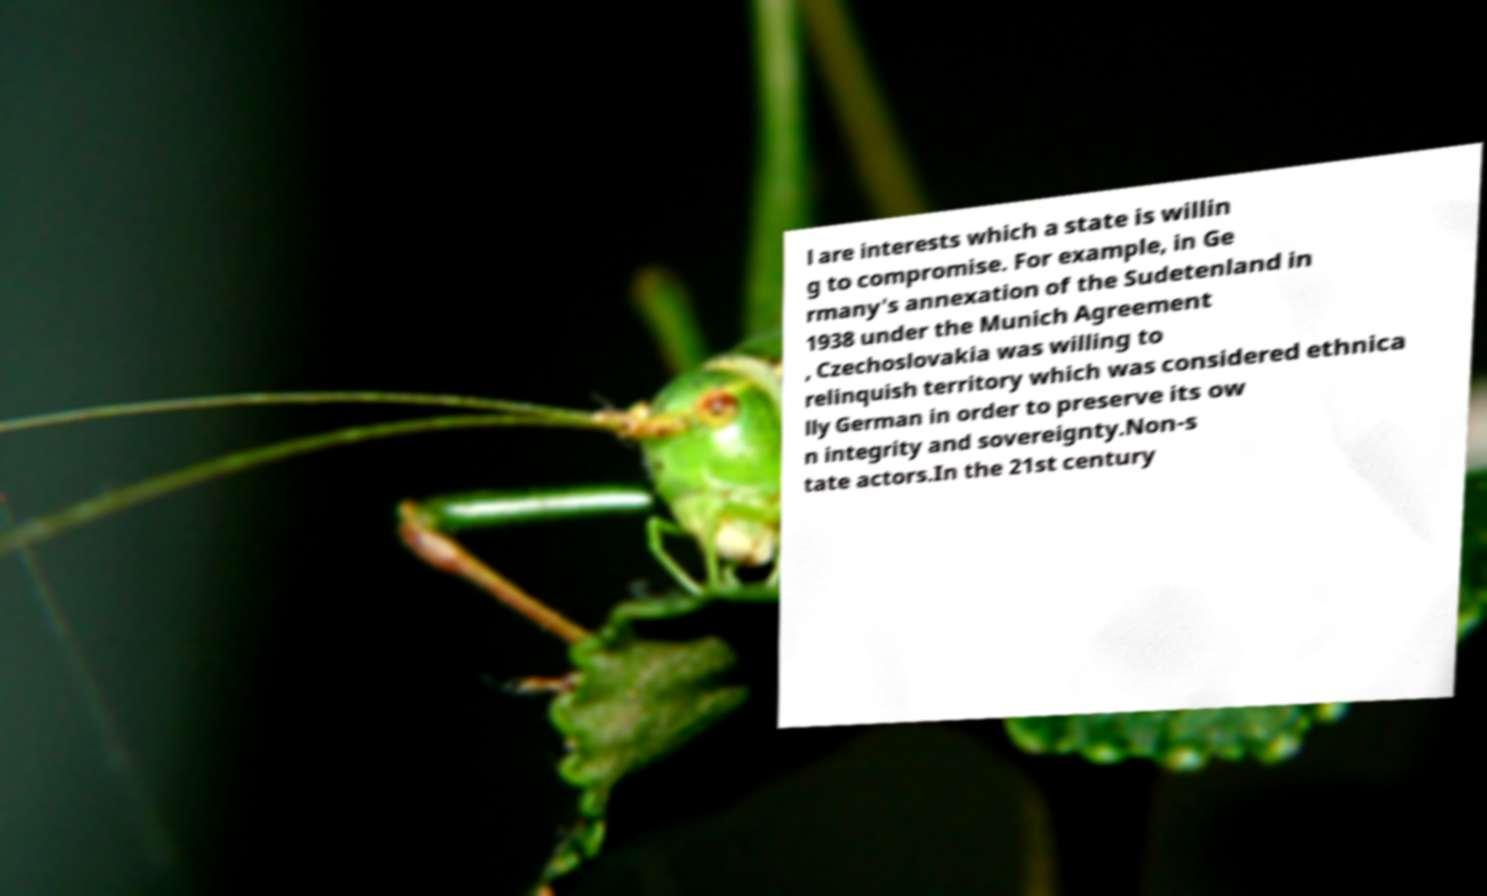Please identify and transcribe the text found in this image. l are interests which a state is willin g to compromise. For example, in Ge rmany's annexation of the Sudetenland in 1938 under the Munich Agreement , Czechoslovakia was willing to relinquish territory which was considered ethnica lly German in order to preserve its ow n integrity and sovereignty.Non-s tate actors.In the 21st century 